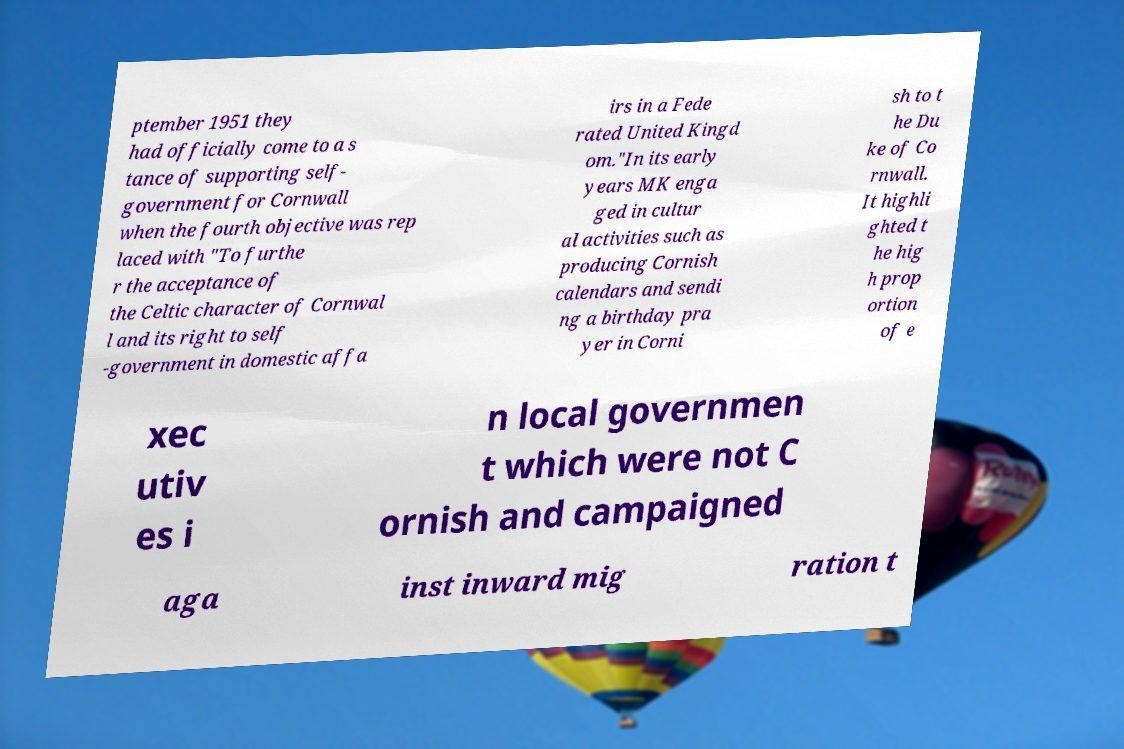For documentation purposes, I need the text within this image transcribed. Could you provide that? ptember 1951 they had officially come to a s tance of supporting self- government for Cornwall when the fourth objective was rep laced with "To furthe r the acceptance of the Celtic character of Cornwal l and its right to self -government in domestic affa irs in a Fede rated United Kingd om."In its early years MK enga ged in cultur al activities such as producing Cornish calendars and sendi ng a birthday pra yer in Corni sh to t he Du ke of Co rnwall. It highli ghted t he hig h prop ortion of e xec utiv es i n local governmen t which were not C ornish and campaigned aga inst inward mig ration t 